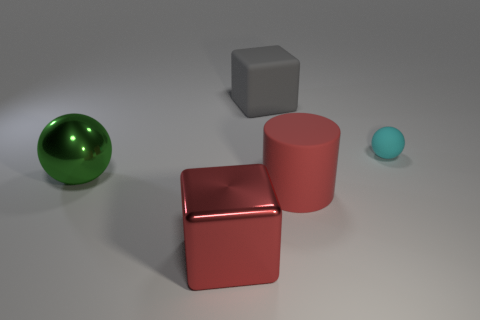Add 3 purple metallic cylinders. How many objects exist? 8 Subtract all cubes. How many objects are left? 3 Add 4 matte objects. How many matte objects are left? 7 Add 2 tiny green cylinders. How many tiny green cylinders exist? 2 Subtract 0 yellow cylinders. How many objects are left? 5 Subtract all big red metallic objects. Subtract all cyan metal balls. How many objects are left? 4 